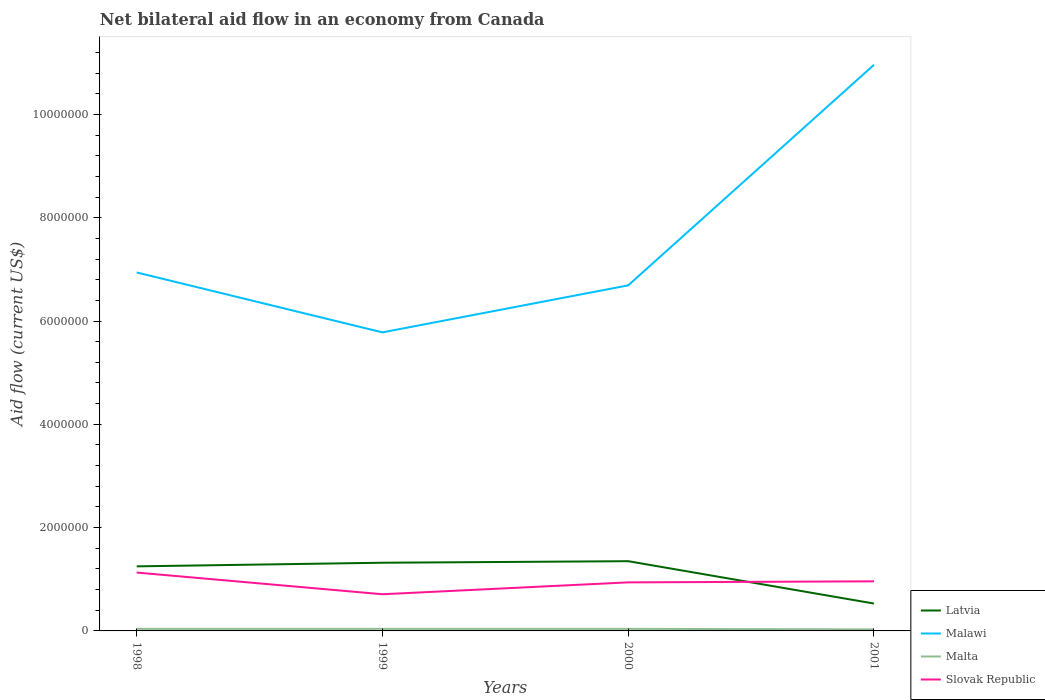Does the line corresponding to Malta intersect with the line corresponding to Malawi?
Ensure brevity in your answer.  No. Across all years, what is the maximum net bilateral aid flow in Malawi?
Your response must be concise. 5.78e+06. What is the total net bilateral aid flow in Latvia in the graph?
Your answer should be very brief. -1.00e+05. What is the difference between the highest and the second highest net bilateral aid flow in Latvia?
Give a very brief answer. 8.20e+05. What is the difference between the highest and the lowest net bilateral aid flow in Malta?
Your response must be concise. 3. How many lines are there?
Make the answer very short. 4. How many years are there in the graph?
Provide a succinct answer. 4. What is the difference between two consecutive major ticks on the Y-axis?
Keep it short and to the point. 2.00e+06. How many legend labels are there?
Provide a short and direct response. 4. How are the legend labels stacked?
Your response must be concise. Vertical. What is the title of the graph?
Your answer should be very brief. Net bilateral aid flow in an economy from Canada. What is the label or title of the X-axis?
Provide a short and direct response. Years. What is the Aid flow (current US$) in Latvia in 1998?
Provide a short and direct response. 1.25e+06. What is the Aid flow (current US$) in Malawi in 1998?
Your answer should be compact. 6.94e+06. What is the Aid flow (current US$) in Slovak Republic in 1998?
Make the answer very short. 1.13e+06. What is the Aid flow (current US$) in Latvia in 1999?
Keep it short and to the point. 1.32e+06. What is the Aid flow (current US$) of Malawi in 1999?
Your answer should be very brief. 5.78e+06. What is the Aid flow (current US$) of Malta in 1999?
Give a very brief answer. 4.00e+04. What is the Aid flow (current US$) of Slovak Republic in 1999?
Make the answer very short. 7.10e+05. What is the Aid flow (current US$) of Latvia in 2000?
Your answer should be compact. 1.35e+06. What is the Aid flow (current US$) in Malawi in 2000?
Ensure brevity in your answer.  6.69e+06. What is the Aid flow (current US$) in Slovak Republic in 2000?
Give a very brief answer. 9.40e+05. What is the Aid flow (current US$) of Latvia in 2001?
Offer a very short reply. 5.30e+05. What is the Aid flow (current US$) in Malawi in 2001?
Provide a short and direct response. 1.10e+07. What is the Aid flow (current US$) of Slovak Republic in 2001?
Your response must be concise. 9.60e+05. Across all years, what is the maximum Aid flow (current US$) in Latvia?
Offer a very short reply. 1.35e+06. Across all years, what is the maximum Aid flow (current US$) of Malawi?
Your answer should be compact. 1.10e+07. Across all years, what is the maximum Aid flow (current US$) in Malta?
Your response must be concise. 4.00e+04. Across all years, what is the maximum Aid flow (current US$) in Slovak Republic?
Offer a terse response. 1.13e+06. Across all years, what is the minimum Aid flow (current US$) in Latvia?
Provide a short and direct response. 5.30e+05. Across all years, what is the minimum Aid flow (current US$) of Malawi?
Offer a very short reply. 5.78e+06. Across all years, what is the minimum Aid flow (current US$) of Slovak Republic?
Provide a short and direct response. 7.10e+05. What is the total Aid flow (current US$) of Latvia in the graph?
Your answer should be very brief. 4.45e+06. What is the total Aid flow (current US$) in Malawi in the graph?
Provide a short and direct response. 3.04e+07. What is the total Aid flow (current US$) in Malta in the graph?
Offer a terse response. 1.50e+05. What is the total Aid flow (current US$) in Slovak Republic in the graph?
Offer a very short reply. 3.74e+06. What is the difference between the Aid flow (current US$) of Malawi in 1998 and that in 1999?
Keep it short and to the point. 1.16e+06. What is the difference between the Aid flow (current US$) in Malta in 1998 and that in 1999?
Make the answer very short. 0. What is the difference between the Aid flow (current US$) in Slovak Republic in 1998 and that in 1999?
Your answer should be very brief. 4.20e+05. What is the difference between the Aid flow (current US$) of Malawi in 1998 and that in 2000?
Your answer should be compact. 2.50e+05. What is the difference between the Aid flow (current US$) in Malta in 1998 and that in 2000?
Offer a very short reply. 0. What is the difference between the Aid flow (current US$) of Slovak Republic in 1998 and that in 2000?
Offer a terse response. 1.90e+05. What is the difference between the Aid flow (current US$) of Latvia in 1998 and that in 2001?
Your answer should be compact. 7.20e+05. What is the difference between the Aid flow (current US$) in Malawi in 1998 and that in 2001?
Make the answer very short. -4.02e+06. What is the difference between the Aid flow (current US$) of Latvia in 1999 and that in 2000?
Ensure brevity in your answer.  -3.00e+04. What is the difference between the Aid flow (current US$) in Malawi in 1999 and that in 2000?
Your response must be concise. -9.10e+05. What is the difference between the Aid flow (current US$) of Slovak Republic in 1999 and that in 2000?
Ensure brevity in your answer.  -2.30e+05. What is the difference between the Aid flow (current US$) of Latvia in 1999 and that in 2001?
Your response must be concise. 7.90e+05. What is the difference between the Aid flow (current US$) of Malawi in 1999 and that in 2001?
Keep it short and to the point. -5.18e+06. What is the difference between the Aid flow (current US$) of Malta in 1999 and that in 2001?
Provide a short and direct response. 10000. What is the difference between the Aid flow (current US$) in Latvia in 2000 and that in 2001?
Your answer should be very brief. 8.20e+05. What is the difference between the Aid flow (current US$) of Malawi in 2000 and that in 2001?
Give a very brief answer. -4.27e+06. What is the difference between the Aid flow (current US$) of Malta in 2000 and that in 2001?
Your answer should be compact. 10000. What is the difference between the Aid flow (current US$) in Slovak Republic in 2000 and that in 2001?
Offer a terse response. -2.00e+04. What is the difference between the Aid flow (current US$) of Latvia in 1998 and the Aid flow (current US$) of Malawi in 1999?
Provide a short and direct response. -4.53e+06. What is the difference between the Aid flow (current US$) in Latvia in 1998 and the Aid flow (current US$) in Malta in 1999?
Provide a succinct answer. 1.21e+06. What is the difference between the Aid flow (current US$) in Latvia in 1998 and the Aid flow (current US$) in Slovak Republic in 1999?
Your answer should be compact. 5.40e+05. What is the difference between the Aid flow (current US$) of Malawi in 1998 and the Aid flow (current US$) of Malta in 1999?
Give a very brief answer. 6.90e+06. What is the difference between the Aid flow (current US$) in Malawi in 1998 and the Aid flow (current US$) in Slovak Republic in 1999?
Ensure brevity in your answer.  6.23e+06. What is the difference between the Aid flow (current US$) of Malta in 1998 and the Aid flow (current US$) of Slovak Republic in 1999?
Your answer should be compact. -6.70e+05. What is the difference between the Aid flow (current US$) in Latvia in 1998 and the Aid flow (current US$) in Malawi in 2000?
Make the answer very short. -5.44e+06. What is the difference between the Aid flow (current US$) in Latvia in 1998 and the Aid flow (current US$) in Malta in 2000?
Your answer should be very brief. 1.21e+06. What is the difference between the Aid flow (current US$) in Latvia in 1998 and the Aid flow (current US$) in Slovak Republic in 2000?
Your answer should be compact. 3.10e+05. What is the difference between the Aid flow (current US$) of Malawi in 1998 and the Aid flow (current US$) of Malta in 2000?
Provide a succinct answer. 6.90e+06. What is the difference between the Aid flow (current US$) in Malawi in 1998 and the Aid flow (current US$) in Slovak Republic in 2000?
Give a very brief answer. 6.00e+06. What is the difference between the Aid flow (current US$) in Malta in 1998 and the Aid flow (current US$) in Slovak Republic in 2000?
Ensure brevity in your answer.  -9.00e+05. What is the difference between the Aid flow (current US$) in Latvia in 1998 and the Aid flow (current US$) in Malawi in 2001?
Your response must be concise. -9.71e+06. What is the difference between the Aid flow (current US$) of Latvia in 1998 and the Aid flow (current US$) of Malta in 2001?
Offer a very short reply. 1.22e+06. What is the difference between the Aid flow (current US$) in Malawi in 1998 and the Aid flow (current US$) in Malta in 2001?
Offer a terse response. 6.91e+06. What is the difference between the Aid flow (current US$) in Malawi in 1998 and the Aid flow (current US$) in Slovak Republic in 2001?
Your response must be concise. 5.98e+06. What is the difference between the Aid flow (current US$) of Malta in 1998 and the Aid flow (current US$) of Slovak Republic in 2001?
Ensure brevity in your answer.  -9.20e+05. What is the difference between the Aid flow (current US$) in Latvia in 1999 and the Aid flow (current US$) in Malawi in 2000?
Your answer should be compact. -5.37e+06. What is the difference between the Aid flow (current US$) of Latvia in 1999 and the Aid flow (current US$) of Malta in 2000?
Provide a succinct answer. 1.28e+06. What is the difference between the Aid flow (current US$) in Latvia in 1999 and the Aid flow (current US$) in Slovak Republic in 2000?
Keep it short and to the point. 3.80e+05. What is the difference between the Aid flow (current US$) in Malawi in 1999 and the Aid flow (current US$) in Malta in 2000?
Offer a terse response. 5.74e+06. What is the difference between the Aid flow (current US$) of Malawi in 1999 and the Aid flow (current US$) of Slovak Republic in 2000?
Your answer should be compact. 4.84e+06. What is the difference between the Aid flow (current US$) of Malta in 1999 and the Aid flow (current US$) of Slovak Republic in 2000?
Make the answer very short. -9.00e+05. What is the difference between the Aid flow (current US$) of Latvia in 1999 and the Aid flow (current US$) of Malawi in 2001?
Offer a terse response. -9.64e+06. What is the difference between the Aid flow (current US$) in Latvia in 1999 and the Aid flow (current US$) in Malta in 2001?
Your answer should be very brief. 1.29e+06. What is the difference between the Aid flow (current US$) of Malawi in 1999 and the Aid flow (current US$) of Malta in 2001?
Keep it short and to the point. 5.75e+06. What is the difference between the Aid flow (current US$) in Malawi in 1999 and the Aid flow (current US$) in Slovak Republic in 2001?
Offer a very short reply. 4.82e+06. What is the difference between the Aid flow (current US$) in Malta in 1999 and the Aid flow (current US$) in Slovak Republic in 2001?
Your answer should be compact. -9.20e+05. What is the difference between the Aid flow (current US$) in Latvia in 2000 and the Aid flow (current US$) in Malawi in 2001?
Your answer should be compact. -9.61e+06. What is the difference between the Aid flow (current US$) in Latvia in 2000 and the Aid flow (current US$) in Malta in 2001?
Make the answer very short. 1.32e+06. What is the difference between the Aid flow (current US$) of Malawi in 2000 and the Aid flow (current US$) of Malta in 2001?
Offer a very short reply. 6.66e+06. What is the difference between the Aid flow (current US$) of Malawi in 2000 and the Aid flow (current US$) of Slovak Republic in 2001?
Give a very brief answer. 5.73e+06. What is the difference between the Aid flow (current US$) of Malta in 2000 and the Aid flow (current US$) of Slovak Republic in 2001?
Provide a short and direct response. -9.20e+05. What is the average Aid flow (current US$) of Latvia per year?
Offer a terse response. 1.11e+06. What is the average Aid flow (current US$) of Malawi per year?
Provide a succinct answer. 7.59e+06. What is the average Aid flow (current US$) in Malta per year?
Your response must be concise. 3.75e+04. What is the average Aid flow (current US$) in Slovak Republic per year?
Keep it short and to the point. 9.35e+05. In the year 1998, what is the difference between the Aid flow (current US$) in Latvia and Aid flow (current US$) in Malawi?
Your answer should be compact. -5.69e+06. In the year 1998, what is the difference between the Aid flow (current US$) of Latvia and Aid flow (current US$) of Malta?
Offer a very short reply. 1.21e+06. In the year 1998, what is the difference between the Aid flow (current US$) of Latvia and Aid flow (current US$) of Slovak Republic?
Give a very brief answer. 1.20e+05. In the year 1998, what is the difference between the Aid flow (current US$) of Malawi and Aid flow (current US$) of Malta?
Make the answer very short. 6.90e+06. In the year 1998, what is the difference between the Aid flow (current US$) in Malawi and Aid flow (current US$) in Slovak Republic?
Offer a terse response. 5.81e+06. In the year 1998, what is the difference between the Aid flow (current US$) of Malta and Aid flow (current US$) of Slovak Republic?
Offer a terse response. -1.09e+06. In the year 1999, what is the difference between the Aid flow (current US$) in Latvia and Aid flow (current US$) in Malawi?
Give a very brief answer. -4.46e+06. In the year 1999, what is the difference between the Aid flow (current US$) in Latvia and Aid flow (current US$) in Malta?
Keep it short and to the point. 1.28e+06. In the year 1999, what is the difference between the Aid flow (current US$) in Latvia and Aid flow (current US$) in Slovak Republic?
Offer a very short reply. 6.10e+05. In the year 1999, what is the difference between the Aid flow (current US$) of Malawi and Aid flow (current US$) of Malta?
Offer a terse response. 5.74e+06. In the year 1999, what is the difference between the Aid flow (current US$) in Malawi and Aid flow (current US$) in Slovak Republic?
Your response must be concise. 5.07e+06. In the year 1999, what is the difference between the Aid flow (current US$) of Malta and Aid flow (current US$) of Slovak Republic?
Keep it short and to the point. -6.70e+05. In the year 2000, what is the difference between the Aid flow (current US$) in Latvia and Aid flow (current US$) in Malawi?
Ensure brevity in your answer.  -5.34e+06. In the year 2000, what is the difference between the Aid flow (current US$) of Latvia and Aid flow (current US$) of Malta?
Offer a terse response. 1.31e+06. In the year 2000, what is the difference between the Aid flow (current US$) of Malawi and Aid flow (current US$) of Malta?
Offer a terse response. 6.65e+06. In the year 2000, what is the difference between the Aid flow (current US$) of Malawi and Aid flow (current US$) of Slovak Republic?
Keep it short and to the point. 5.75e+06. In the year 2000, what is the difference between the Aid flow (current US$) of Malta and Aid flow (current US$) of Slovak Republic?
Provide a succinct answer. -9.00e+05. In the year 2001, what is the difference between the Aid flow (current US$) of Latvia and Aid flow (current US$) of Malawi?
Your response must be concise. -1.04e+07. In the year 2001, what is the difference between the Aid flow (current US$) in Latvia and Aid flow (current US$) in Malta?
Keep it short and to the point. 5.00e+05. In the year 2001, what is the difference between the Aid flow (current US$) in Latvia and Aid flow (current US$) in Slovak Republic?
Give a very brief answer. -4.30e+05. In the year 2001, what is the difference between the Aid flow (current US$) of Malawi and Aid flow (current US$) of Malta?
Your response must be concise. 1.09e+07. In the year 2001, what is the difference between the Aid flow (current US$) in Malawi and Aid flow (current US$) in Slovak Republic?
Your answer should be compact. 1.00e+07. In the year 2001, what is the difference between the Aid flow (current US$) in Malta and Aid flow (current US$) in Slovak Republic?
Offer a very short reply. -9.30e+05. What is the ratio of the Aid flow (current US$) in Latvia in 1998 to that in 1999?
Your answer should be compact. 0.95. What is the ratio of the Aid flow (current US$) of Malawi in 1998 to that in 1999?
Give a very brief answer. 1.2. What is the ratio of the Aid flow (current US$) in Slovak Republic in 1998 to that in 1999?
Keep it short and to the point. 1.59. What is the ratio of the Aid flow (current US$) of Latvia in 1998 to that in 2000?
Ensure brevity in your answer.  0.93. What is the ratio of the Aid flow (current US$) of Malawi in 1998 to that in 2000?
Make the answer very short. 1.04. What is the ratio of the Aid flow (current US$) in Malta in 1998 to that in 2000?
Your answer should be very brief. 1. What is the ratio of the Aid flow (current US$) in Slovak Republic in 1998 to that in 2000?
Provide a succinct answer. 1.2. What is the ratio of the Aid flow (current US$) in Latvia in 1998 to that in 2001?
Keep it short and to the point. 2.36. What is the ratio of the Aid flow (current US$) of Malawi in 1998 to that in 2001?
Make the answer very short. 0.63. What is the ratio of the Aid flow (current US$) of Malta in 1998 to that in 2001?
Provide a succinct answer. 1.33. What is the ratio of the Aid flow (current US$) of Slovak Republic in 1998 to that in 2001?
Ensure brevity in your answer.  1.18. What is the ratio of the Aid flow (current US$) in Latvia in 1999 to that in 2000?
Provide a short and direct response. 0.98. What is the ratio of the Aid flow (current US$) in Malawi in 1999 to that in 2000?
Offer a very short reply. 0.86. What is the ratio of the Aid flow (current US$) of Slovak Republic in 1999 to that in 2000?
Offer a very short reply. 0.76. What is the ratio of the Aid flow (current US$) of Latvia in 1999 to that in 2001?
Provide a short and direct response. 2.49. What is the ratio of the Aid flow (current US$) of Malawi in 1999 to that in 2001?
Your answer should be very brief. 0.53. What is the ratio of the Aid flow (current US$) of Slovak Republic in 1999 to that in 2001?
Provide a succinct answer. 0.74. What is the ratio of the Aid flow (current US$) in Latvia in 2000 to that in 2001?
Provide a short and direct response. 2.55. What is the ratio of the Aid flow (current US$) in Malawi in 2000 to that in 2001?
Provide a short and direct response. 0.61. What is the ratio of the Aid flow (current US$) of Malta in 2000 to that in 2001?
Give a very brief answer. 1.33. What is the ratio of the Aid flow (current US$) of Slovak Republic in 2000 to that in 2001?
Your answer should be compact. 0.98. What is the difference between the highest and the second highest Aid flow (current US$) of Malawi?
Ensure brevity in your answer.  4.02e+06. What is the difference between the highest and the second highest Aid flow (current US$) of Malta?
Keep it short and to the point. 0. What is the difference between the highest and the lowest Aid flow (current US$) in Latvia?
Your answer should be very brief. 8.20e+05. What is the difference between the highest and the lowest Aid flow (current US$) in Malawi?
Your answer should be very brief. 5.18e+06. 